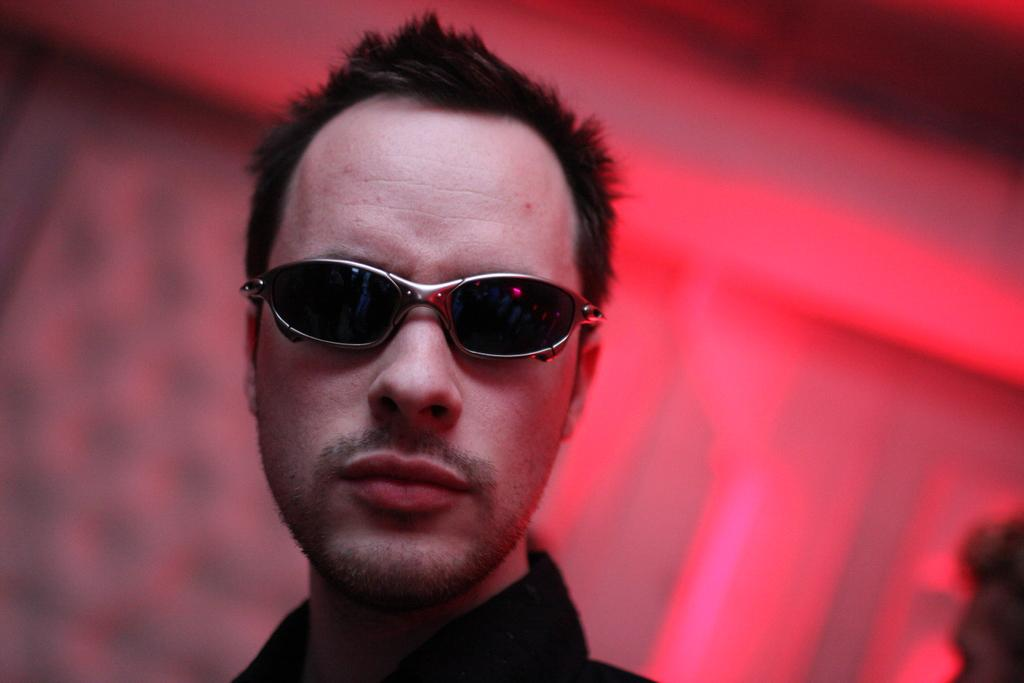What is the main subject of the image? There is a person in the image. Can you describe the person's appearance? The person is wearing spectacles. What color are the spectacles? The spectacles are black in color. How many eggs are used to create the rhythm in the image? There are no eggs or rhythm present in the image; it features a person wearing black spectacles. 